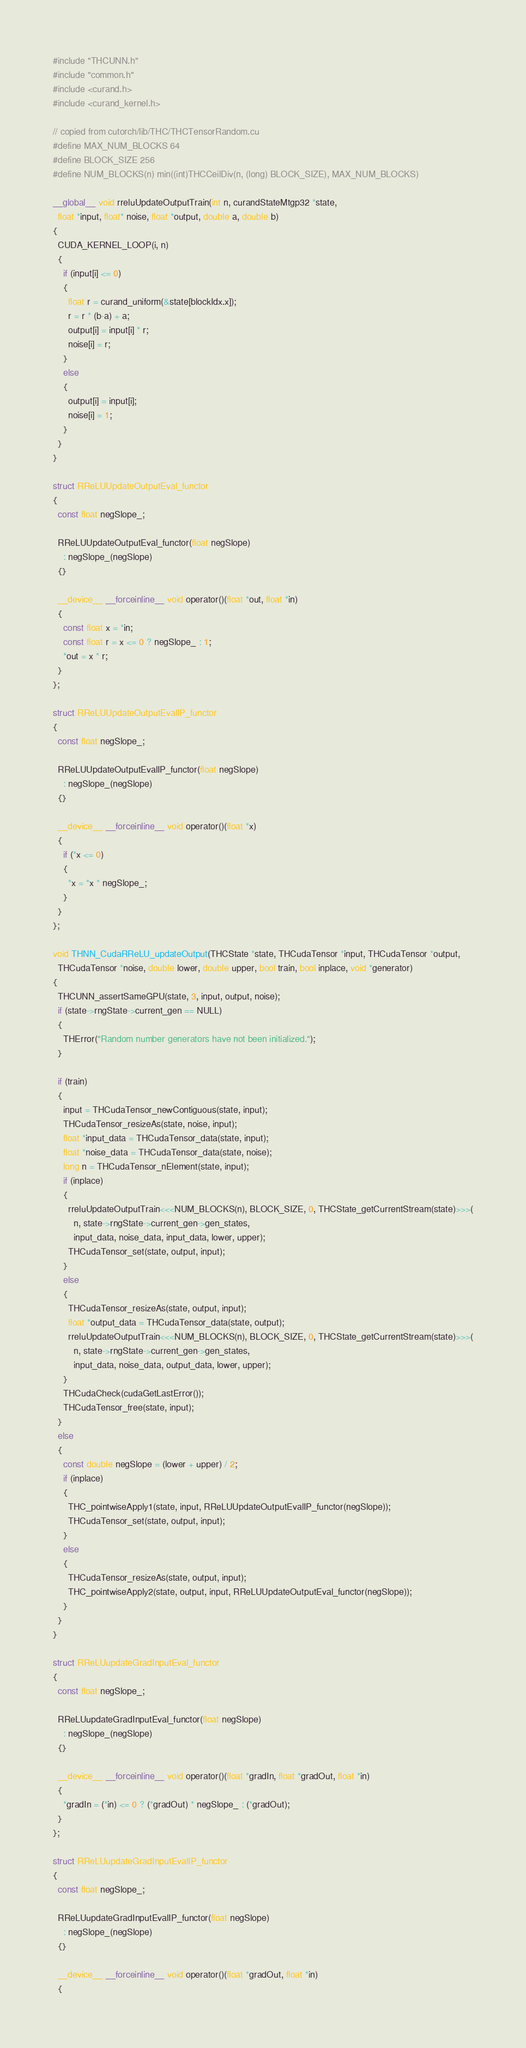Convert code to text. <code><loc_0><loc_0><loc_500><loc_500><_Cuda_>#include "THCUNN.h"
#include "common.h"
#include <curand.h>
#include <curand_kernel.h>

// copied from cutorch/lib/THC/THCTensorRandom.cu
#define MAX_NUM_BLOCKS 64
#define BLOCK_SIZE 256
#define NUM_BLOCKS(n) min((int)THCCeilDiv(n, (long) BLOCK_SIZE), MAX_NUM_BLOCKS)

__global__ void rreluUpdateOutputTrain(int n, curandStateMtgp32 *state,
  float *input, float* noise, float *output, double a, double b)
{
  CUDA_KERNEL_LOOP(i, n)
  {
    if (input[i] <= 0)
    {
      float r = curand_uniform(&state[blockIdx.x]);
      r = r * (b-a) + a;
      output[i] = input[i] * r;
      noise[i] = r;
    }
    else
    {
      output[i] = input[i];
      noise[i] = 1;
    }
  }
}

struct RReLUUpdateOutputEval_functor
{
  const float negSlope_;

  RReLUUpdateOutputEval_functor(float negSlope)
    : negSlope_(negSlope)
  {}

  __device__ __forceinline__ void operator()(float *out, float *in)
  {
    const float x = *in;
    const float r = x <= 0 ? negSlope_ : 1;
    *out = x * r;
  }
};

struct RReLUUpdateOutputEvalIP_functor
{
  const float negSlope_;

  RReLUUpdateOutputEvalIP_functor(float negSlope)
    : negSlope_(negSlope)
  {}

  __device__ __forceinline__ void operator()(float *x)
  {
    if (*x <= 0)
    {
      *x = *x * negSlope_;
    }
  }
};

void THNN_CudaRReLU_updateOutput(THCState *state, THCudaTensor *input, THCudaTensor *output,
  THCudaTensor *noise, double lower, double upper, bool train, bool inplace, void *generator)
{
  THCUNN_assertSameGPU(state, 3, input, output, noise);
  if (state->rngState->current_gen == NULL)
  {
    THError("Random number generators have not been initialized.");
  }

  if (train)
  {
    input = THCudaTensor_newContiguous(state, input);
    THCudaTensor_resizeAs(state, noise, input);
    float *input_data = THCudaTensor_data(state, input);
    float *noise_data = THCudaTensor_data(state, noise);
    long n = THCudaTensor_nElement(state, input);
    if (inplace)
    {
      rreluUpdateOutputTrain<<<NUM_BLOCKS(n), BLOCK_SIZE, 0, THCState_getCurrentStream(state)>>>(
        n, state->rngState->current_gen->gen_states,
        input_data, noise_data, input_data, lower, upper);
      THCudaTensor_set(state, output, input);
    }
    else
    {
      THCudaTensor_resizeAs(state, output, input);
      float *output_data = THCudaTensor_data(state, output);
      rreluUpdateOutputTrain<<<NUM_BLOCKS(n), BLOCK_SIZE, 0, THCState_getCurrentStream(state)>>>(
        n, state->rngState->current_gen->gen_states,
        input_data, noise_data, output_data, lower, upper);
    }
    THCudaCheck(cudaGetLastError());
    THCudaTensor_free(state, input);
  }
  else
  {
    const double negSlope = (lower + upper) / 2;
    if (inplace)
    {
      THC_pointwiseApply1(state, input, RReLUUpdateOutputEvalIP_functor(negSlope));
      THCudaTensor_set(state, output, input);
    }
    else
    {
      THCudaTensor_resizeAs(state, output, input);
      THC_pointwiseApply2(state, output, input, RReLUUpdateOutputEval_functor(negSlope));
    }
  }
}

struct RReLUupdateGradInputEval_functor
{
  const float negSlope_;

  RReLUupdateGradInputEval_functor(float negSlope)
    : negSlope_(negSlope)
  {}

  __device__ __forceinline__ void operator()(float *gradIn, float *gradOut, float *in)
  {
    *gradIn = (*in) <= 0 ? (*gradOut) * negSlope_ : (*gradOut);
  }
};

struct RReLUupdateGradInputEvalIP_functor
{
  const float negSlope_;

  RReLUupdateGradInputEvalIP_functor(float negSlope)
    : negSlope_(negSlope)
  {}

  __device__ __forceinline__ void operator()(float *gradOut, float *in)
  {</code> 